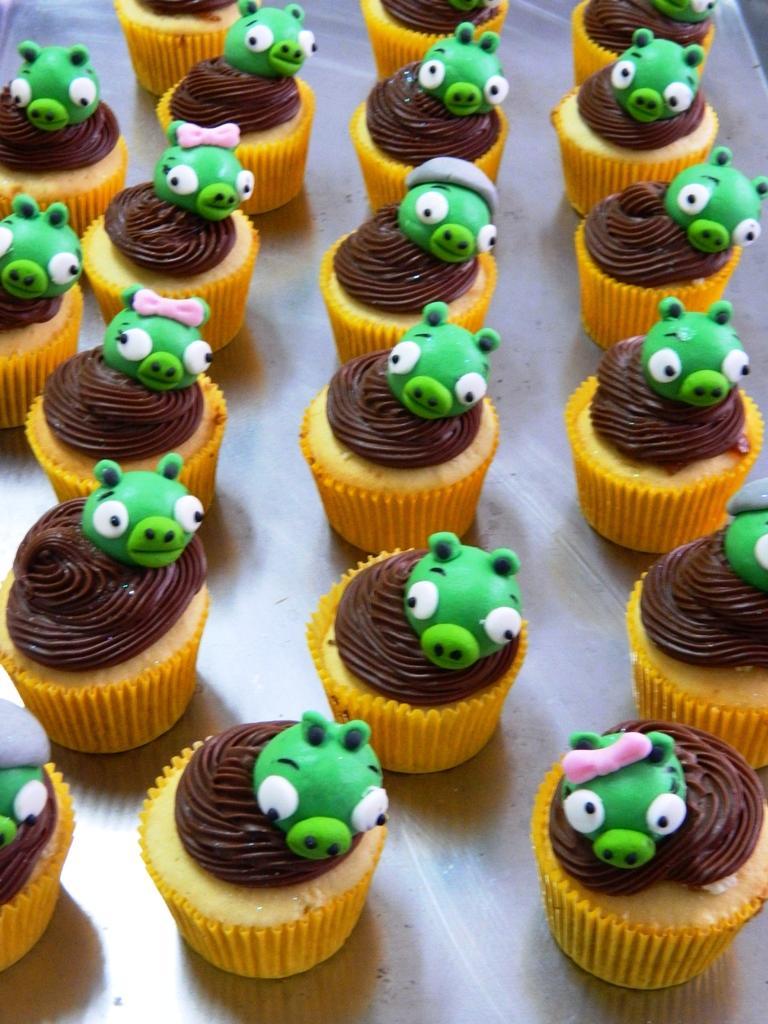Describe this image in one or two sentences. In this image I see number of cupcakes which are of brown and orange in color and I see cartoon faces on each cupcake and I see that those cartoon faces are of green in color. 